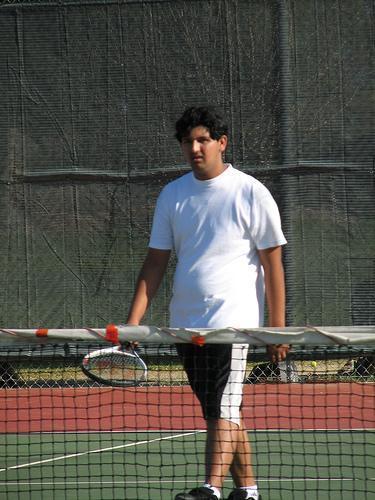How many people?
Give a very brief answer. 1. 